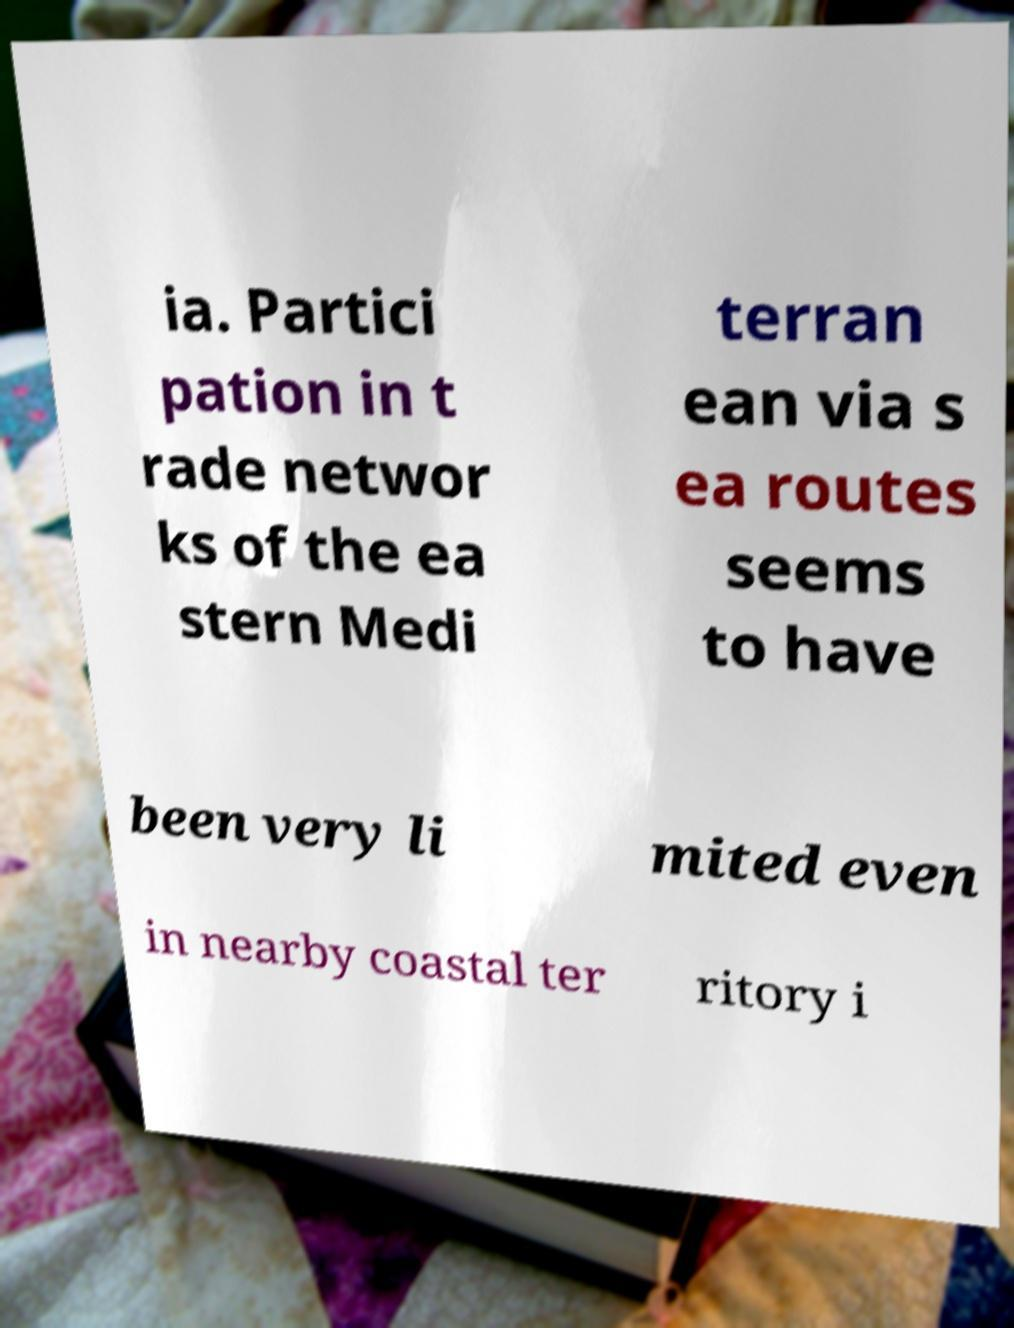There's text embedded in this image that I need extracted. Can you transcribe it verbatim? ia. Partici pation in t rade networ ks of the ea stern Medi terran ean via s ea routes seems to have been very li mited even in nearby coastal ter ritory i 